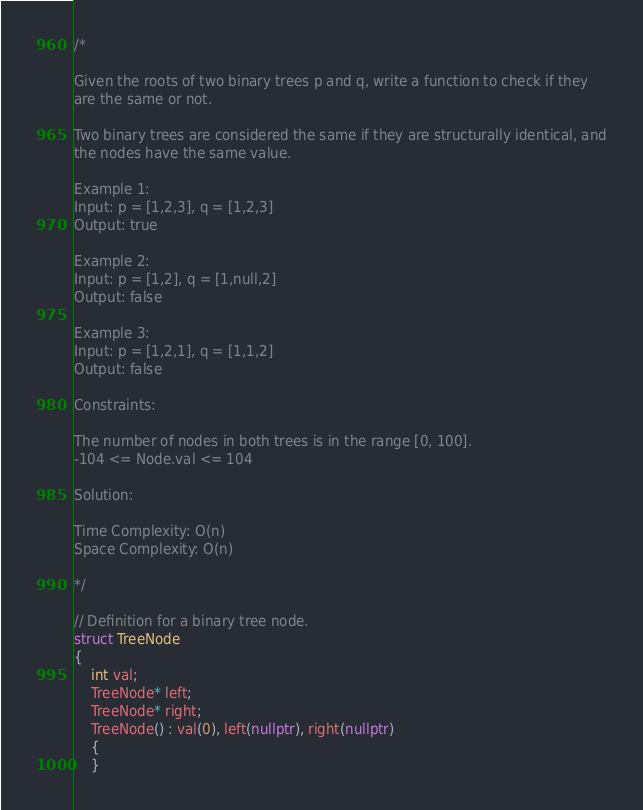Convert code to text. <code><loc_0><loc_0><loc_500><loc_500><_C++_>/*

Given the roots of two binary trees p and q, write a function to check if they
are the same or not.

Two binary trees are considered the same if they are structurally identical, and
the nodes have the same value.

Example 1:
Input: p = [1,2,3], q = [1,2,3]
Output: true

Example 2:
Input: p = [1,2], q = [1,null,2]
Output: false

Example 3:
Input: p = [1,2,1], q = [1,1,2]
Output: false

Constraints:

The number of nodes in both trees is in the range [0, 100].
-104 <= Node.val <= 104

Solution:

Time Complexity: O(n)
Space Complexity: O(n)

*/

// Definition for a binary tree node.
struct TreeNode
{
    int val;
    TreeNode* left;
    TreeNode* right;
    TreeNode() : val(0), left(nullptr), right(nullptr)
    {
    }</code> 